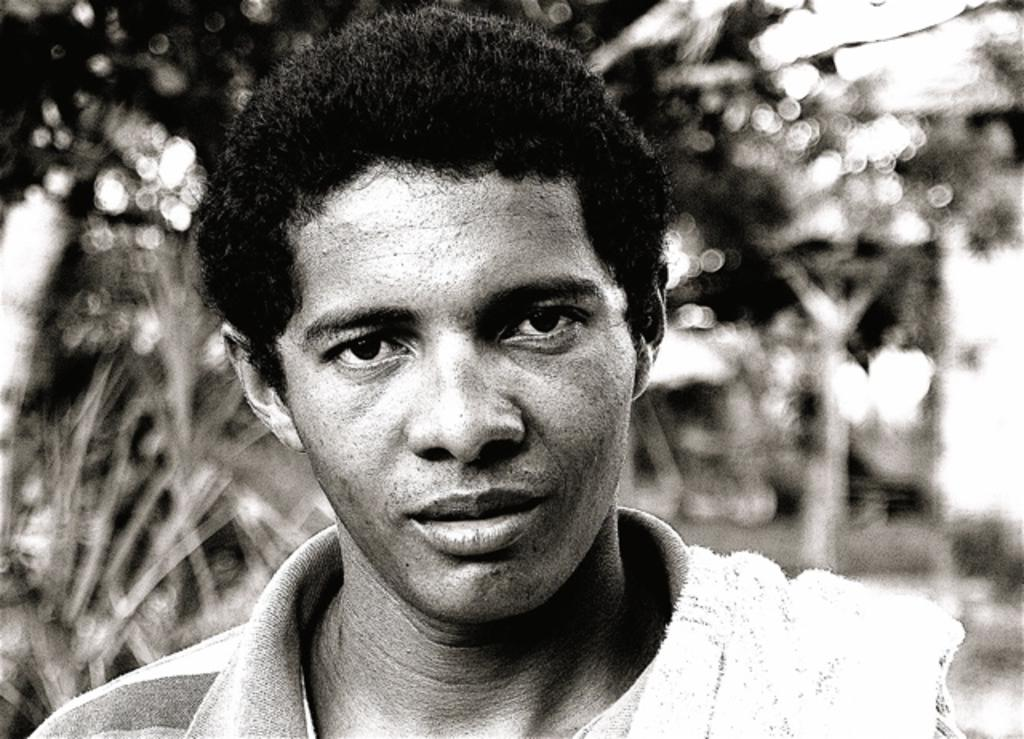What is the color scheme of the image? The image is black and white. Who or what is the main subject in the image? There is a man in the image. Can you describe the background of the image? The background of the image is blurred. How many sheep can be seen in the image? There are no sheep present in the image. What type of pen is being used by the man in the image? There is no pen visible in the image, and the man is not using one. 